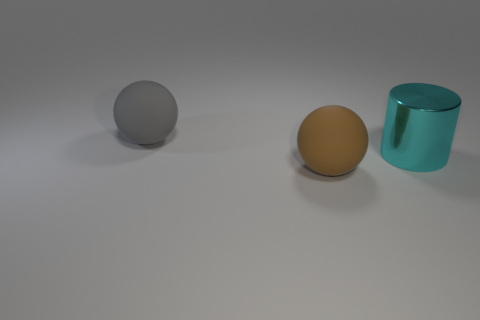Is there another object of the same shape as the brown rubber thing?
Provide a succinct answer. Yes. There is a big gray object; is it the same shape as the brown rubber thing that is on the left side of the cylinder?
Provide a short and direct response. Yes. Is the shape of the gray rubber thing the same as the brown object?
Offer a terse response. Yes. How many cyan objects are big rubber balls or large shiny cylinders?
Keep it short and to the point. 1. What is the color of the ball that is the same material as the brown thing?
Give a very brief answer. Gray. What number of tiny things are either brown rubber spheres or rubber balls?
Keep it short and to the point. 0. Are there fewer gray matte balls than small cyan cubes?
Your answer should be very brief. No. There is another rubber object that is the same shape as the brown rubber object; what is its color?
Your response must be concise. Gray. Are there any other things that are the same shape as the big cyan object?
Offer a very short reply. No. Are there more gray rubber spheres than matte things?
Provide a succinct answer. No. 